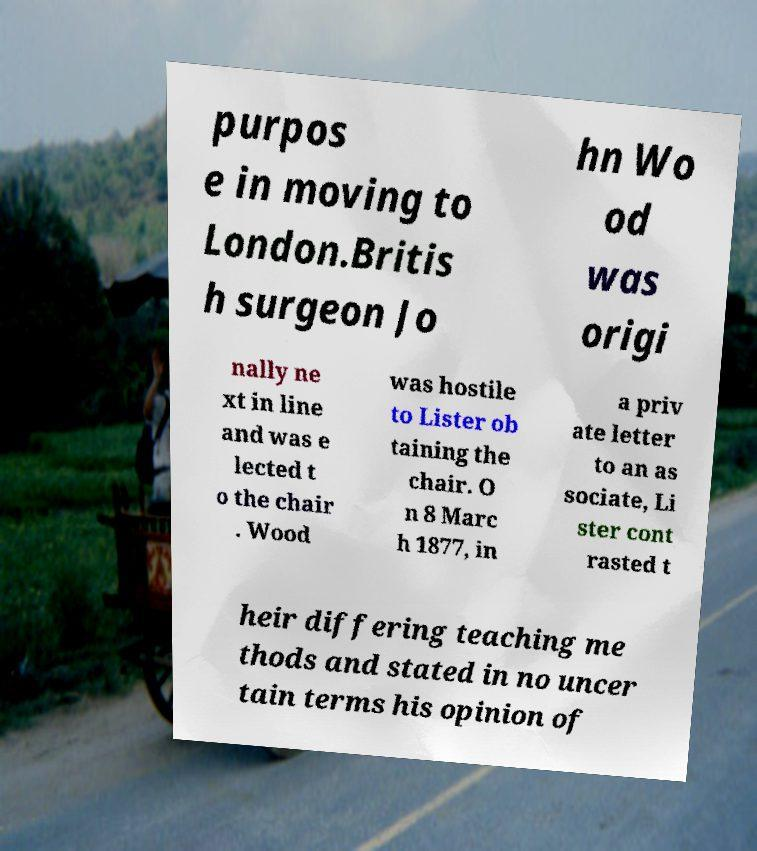What messages or text are displayed in this image? I need them in a readable, typed format. purpos e in moving to London.Britis h surgeon Jo hn Wo od was origi nally ne xt in line and was e lected t o the chair . Wood was hostile to Lister ob taining the chair. O n 8 Marc h 1877, in a priv ate letter to an as sociate, Li ster cont rasted t heir differing teaching me thods and stated in no uncer tain terms his opinion of 